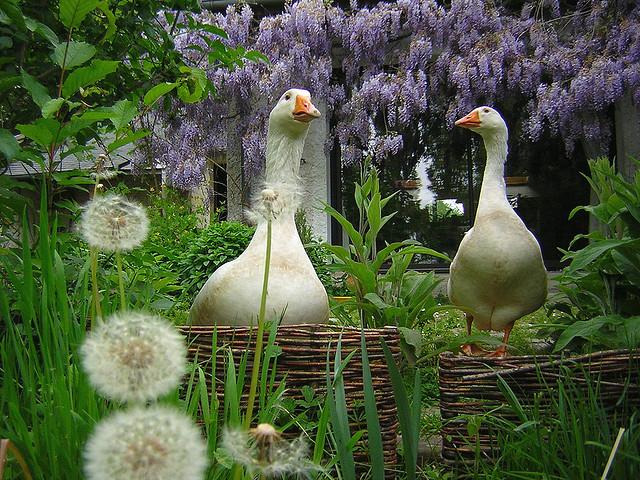What color are the flowers behind the ducks?
Be succinct. Purple. How are this animals called?
Be succinct. Geese. How many ducks can be seen?
Give a very brief answer. 2. 